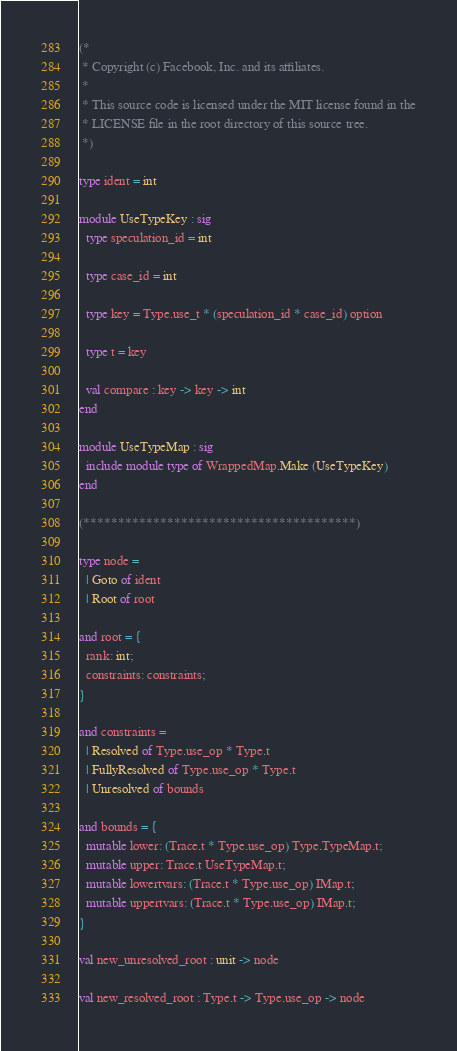<code> <loc_0><loc_0><loc_500><loc_500><_OCaml_>(*
 * Copyright (c) Facebook, Inc. and its affiliates.
 *
 * This source code is licensed under the MIT license found in the
 * LICENSE file in the root directory of this source tree.
 *)

type ident = int

module UseTypeKey : sig
  type speculation_id = int

  type case_id = int

  type key = Type.use_t * (speculation_id * case_id) option

  type t = key

  val compare : key -> key -> int
end

module UseTypeMap : sig
  include module type of WrappedMap.Make (UseTypeKey)
end

(***************************************)

type node =
  | Goto of ident
  | Root of root

and root = {
  rank: int;
  constraints: constraints;
}

and constraints =
  | Resolved of Type.use_op * Type.t
  | FullyResolved of Type.use_op * Type.t
  | Unresolved of bounds

and bounds = {
  mutable lower: (Trace.t * Type.use_op) Type.TypeMap.t;
  mutable upper: Trace.t UseTypeMap.t;
  mutable lowertvars: (Trace.t * Type.use_op) IMap.t;
  mutable uppertvars: (Trace.t * Type.use_op) IMap.t;
}

val new_unresolved_root : unit -> node

val new_resolved_root : Type.t -> Type.use_op -> node
</code> 